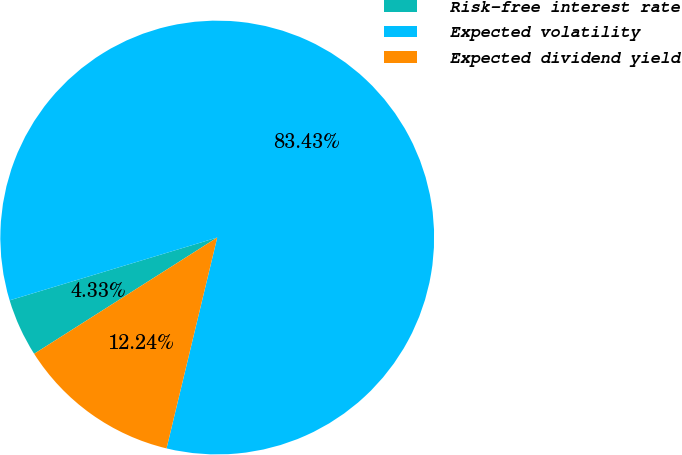Convert chart. <chart><loc_0><loc_0><loc_500><loc_500><pie_chart><fcel>Risk-free interest rate<fcel>Expected volatility<fcel>Expected dividend yield<nl><fcel>4.33%<fcel>83.44%<fcel>12.24%<nl></chart> 